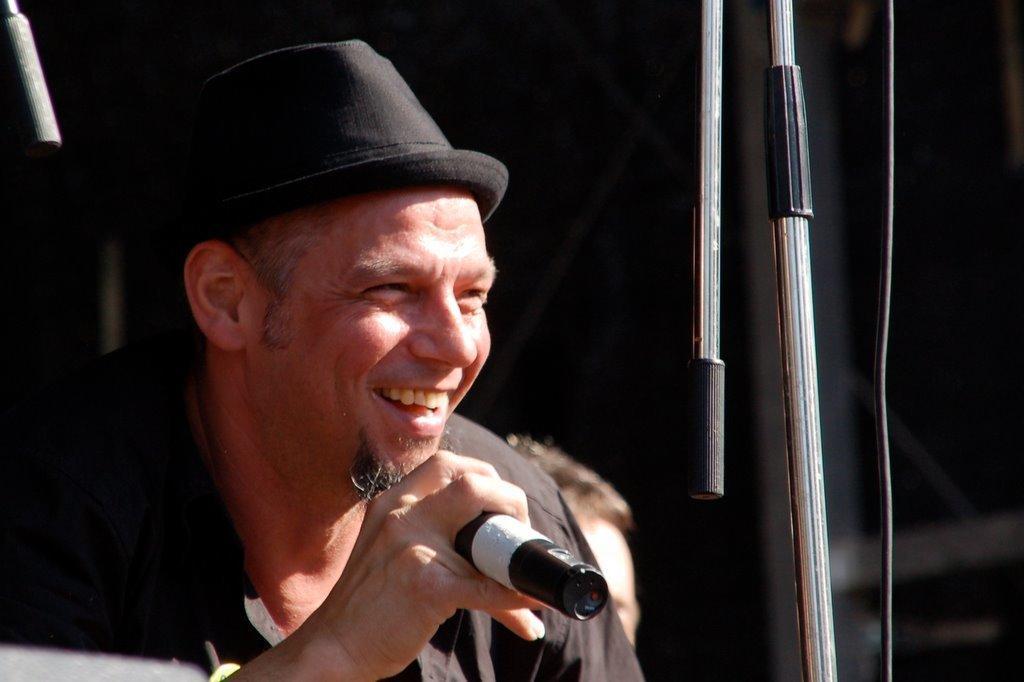Please provide a concise description of this image. In this picture we can see a man smiling and holding a microphone in his right hand, he is wearing a hat. There is a person behind him. 